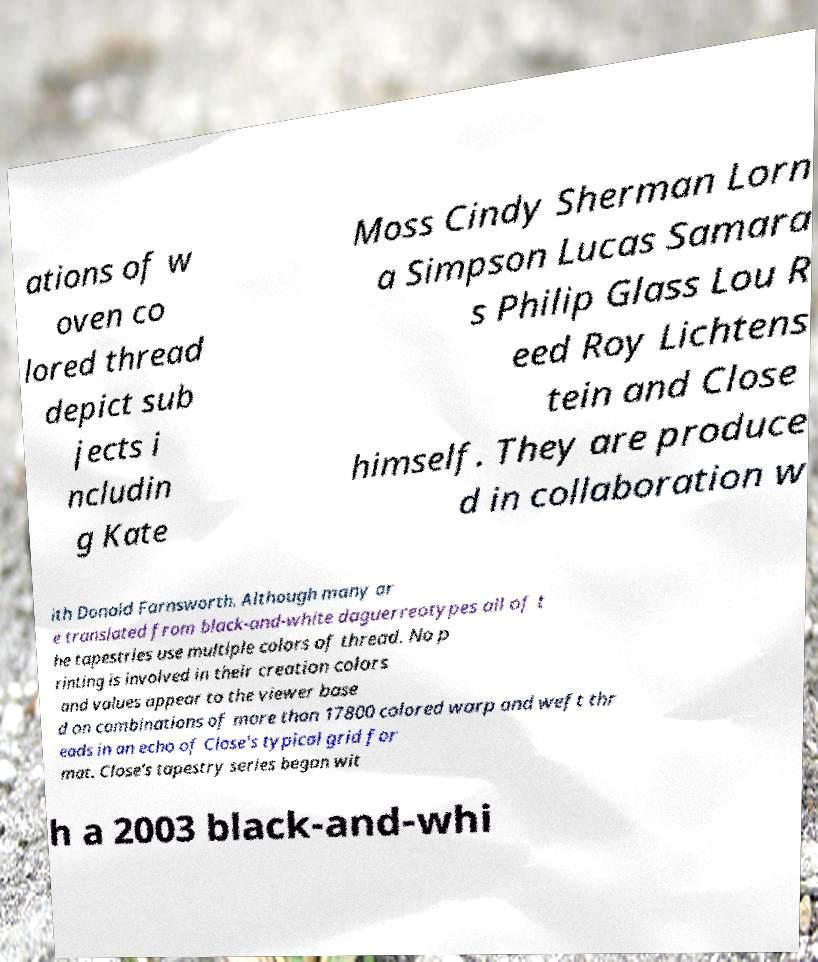Can you read and provide the text displayed in the image?This photo seems to have some interesting text. Can you extract and type it out for me? ations of w oven co lored thread depict sub jects i ncludin g Kate Moss Cindy Sherman Lorn a Simpson Lucas Samara s Philip Glass Lou R eed Roy Lichtens tein and Close himself. They are produce d in collaboration w ith Donald Farnsworth. Although many ar e translated from black-and-white daguerreotypes all of t he tapestries use multiple colors of thread. No p rinting is involved in their creation colors and values appear to the viewer base d on combinations of more than 17800 colored warp and weft thr eads in an echo of Close's typical grid for mat. Close's tapestry series began wit h a 2003 black-and-whi 